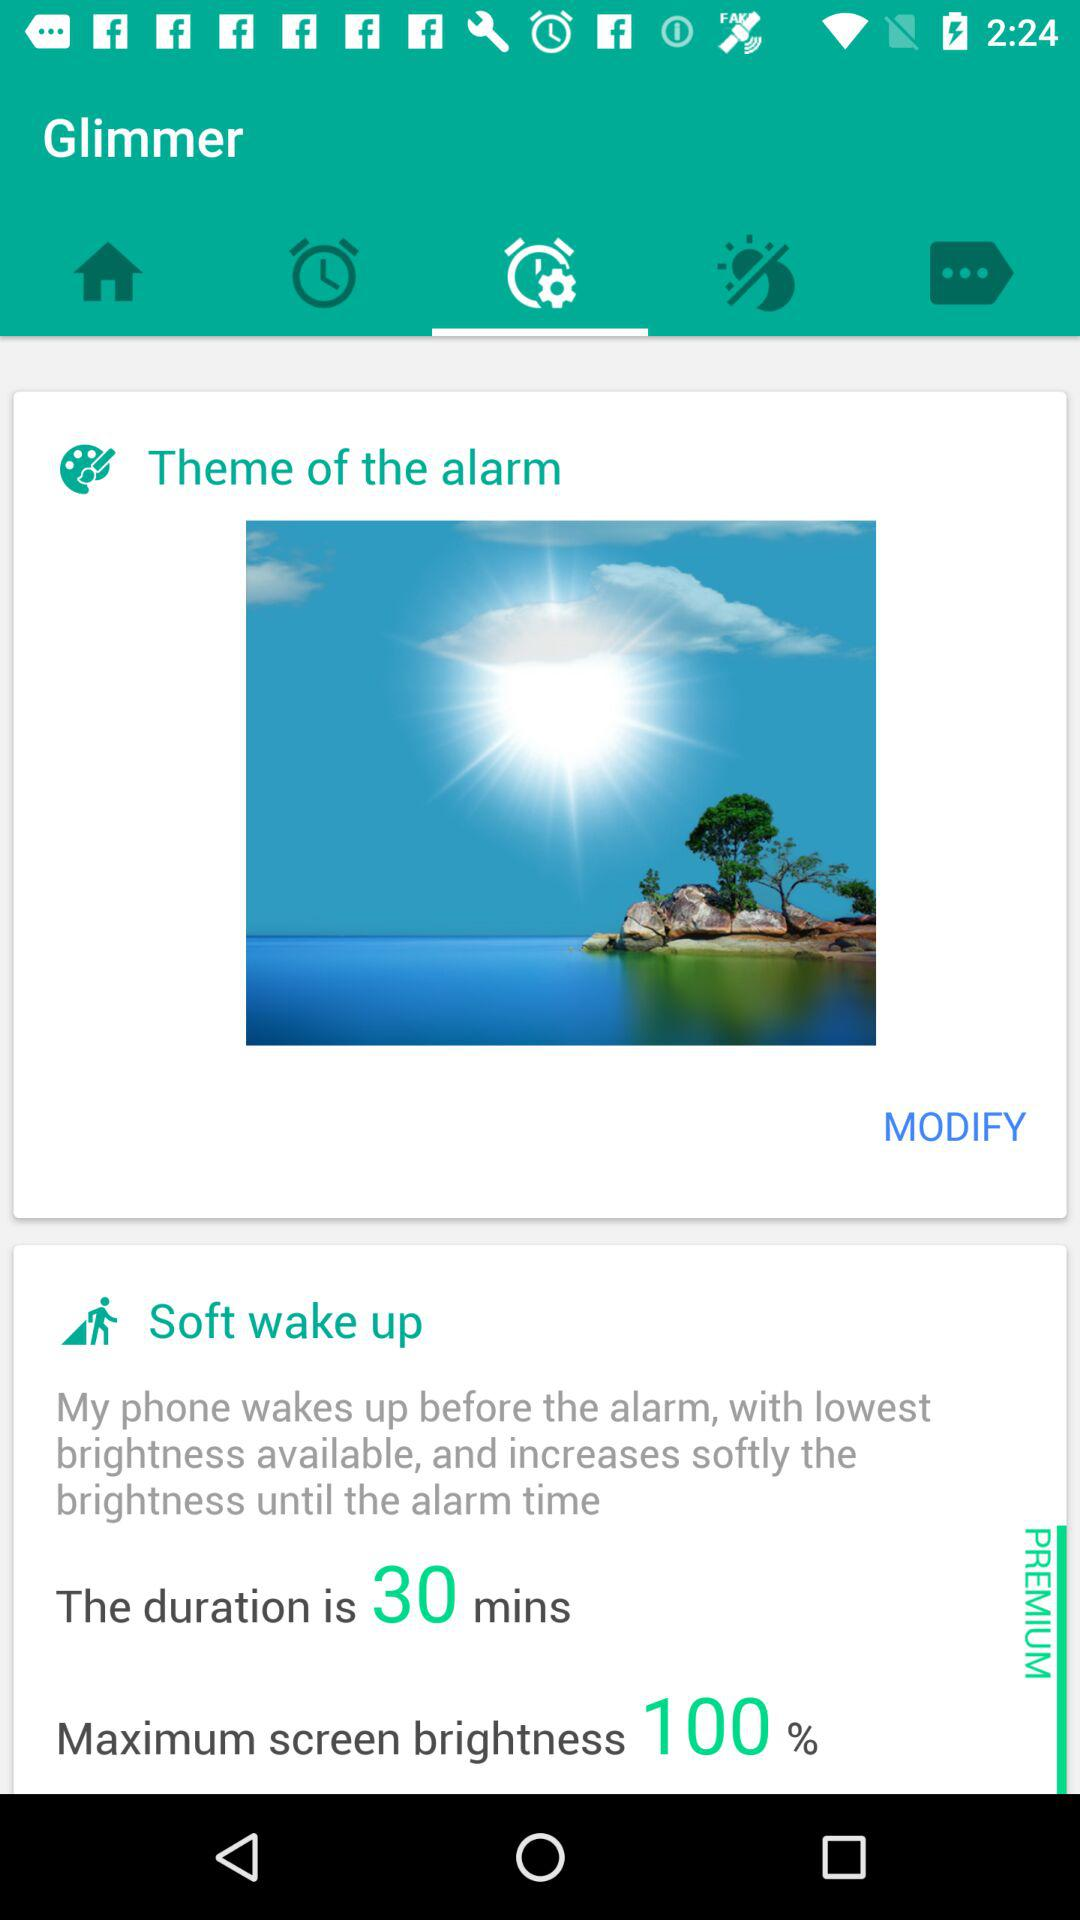What is the duration of soft wake up? The duration is 30 minutes. 